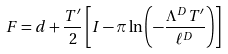<formula> <loc_0><loc_0><loc_500><loc_500>F = d + \frac { T ^ { \prime } } { 2 } \left [ I - \pi \ln \left ( - \frac { \Lambda ^ { D } T ^ { \prime } } { \ell ^ { D } } \right ) \right ]</formula> 